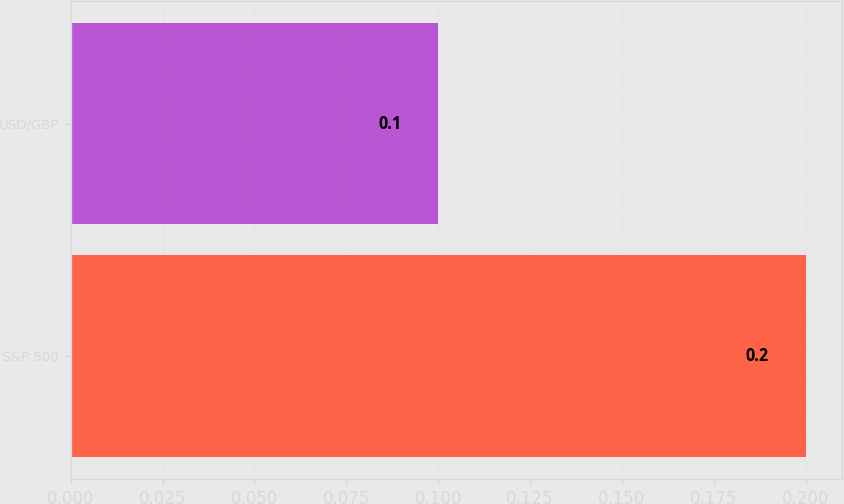Convert chart. <chart><loc_0><loc_0><loc_500><loc_500><bar_chart><fcel>S&P 500<fcel>USD/GBP<nl><fcel>0.2<fcel>0.1<nl></chart> 